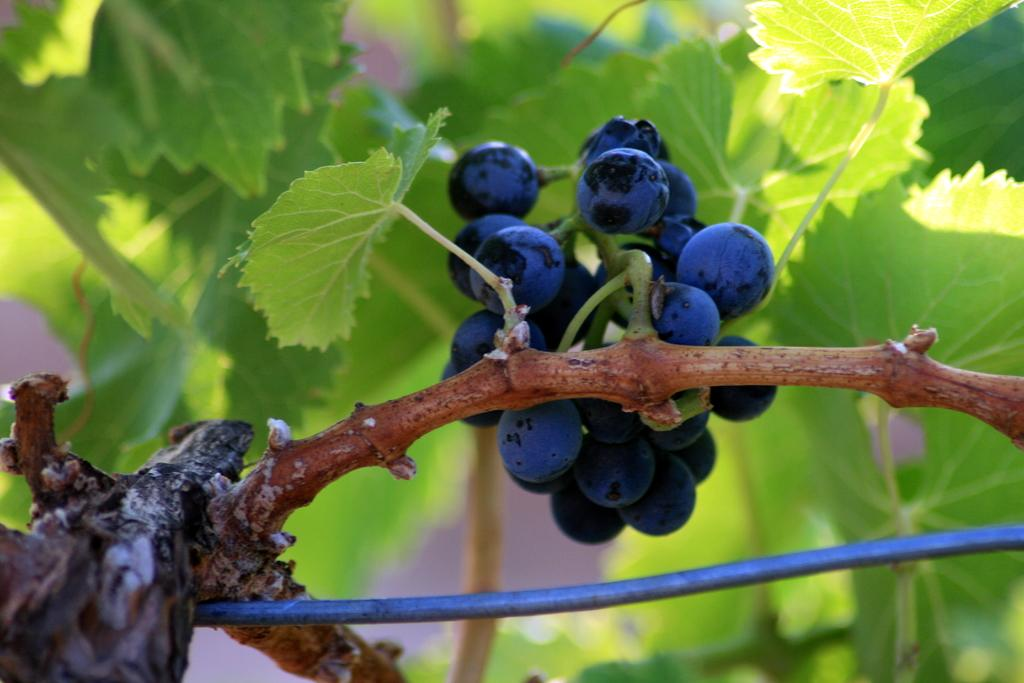What type of plant is present in the image? There is a tree with fruits in the image. What object can be seen on the left side of the image? There is a wooden rod on the left side of the image. What type of material is visible at the bottom of the image? There is a wire visible at the bottom of the image. What type of question can be seen hanging from the tree in the image? There is no question present in the image; it features a tree with fruits, a wooden rod, and a wire. What type of bead is visible on the tree in the image? There are no beads present on the tree in the image; it has fruits instead. 